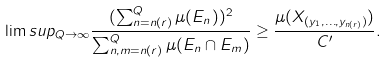<formula> <loc_0><loc_0><loc_500><loc_500>\lim s u p _ { Q \to \infty } \frac { ( \sum _ { n = n ( r ) } ^ { Q } \mu ( E _ { n } ) ) ^ { 2 } } { \sum _ { n , m = n ( r ) } ^ { Q } \mu ( E _ { n } \cap E _ { m } ) } \geq \frac { \mu ( X _ { ( y _ { 1 } , \dots , y _ { n ( r ) } ) } ) } { C ^ { \prime } } .</formula> 